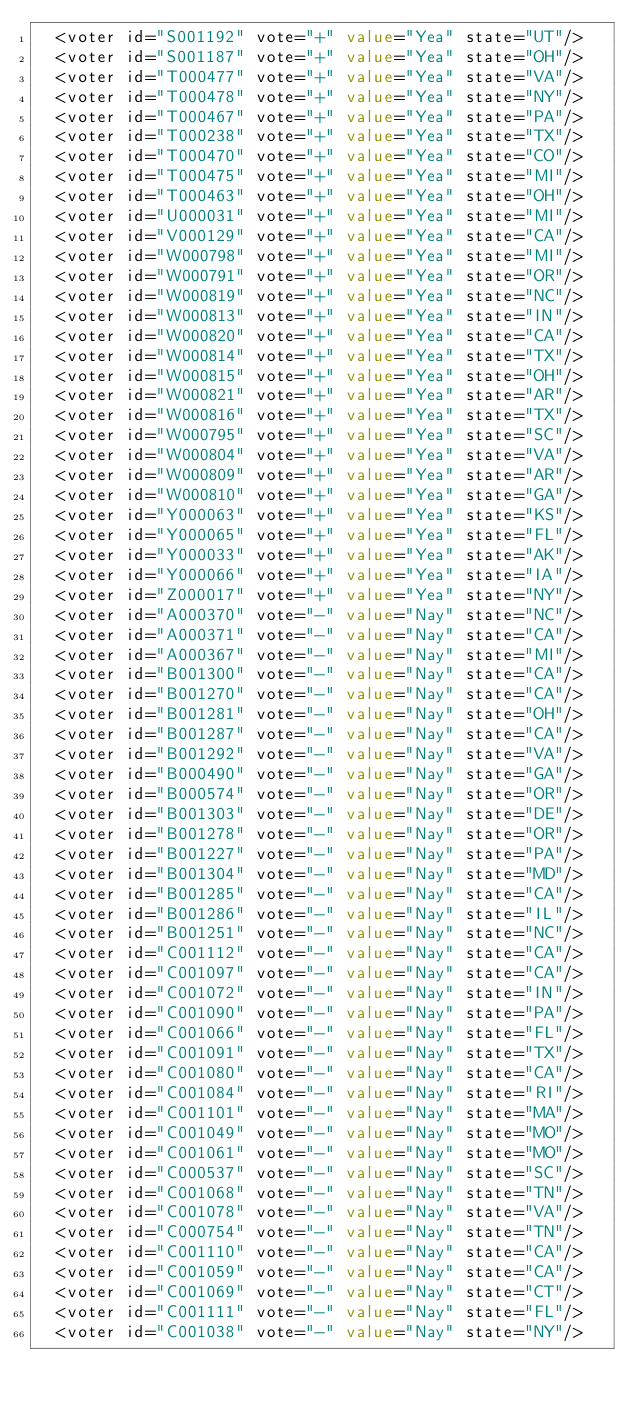Convert code to text. <code><loc_0><loc_0><loc_500><loc_500><_XML_>  <voter id="S001192" vote="+" value="Yea" state="UT"/>
  <voter id="S001187" vote="+" value="Yea" state="OH"/>
  <voter id="T000477" vote="+" value="Yea" state="VA"/>
  <voter id="T000478" vote="+" value="Yea" state="NY"/>
  <voter id="T000467" vote="+" value="Yea" state="PA"/>
  <voter id="T000238" vote="+" value="Yea" state="TX"/>
  <voter id="T000470" vote="+" value="Yea" state="CO"/>
  <voter id="T000475" vote="+" value="Yea" state="MI"/>
  <voter id="T000463" vote="+" value="Yea" state="OH"/>
  <voter id="U000031" vote="+" value="Yea" state="MI"/>
  <voter id="V000129" vote="+" value="Yea" state="CA"/>
  <voter id="W000798" vote="+" value="Yea" state="MI"/>
  <voter id="W000791" vote="+" value="Yea" state="OR"/>
  <voter id="W000819" vote="+" value="Yea" state="NC"/>
  <voter id="W000813" vote="+" value="Yea" state="IN"/>
  <voter id="W000820" vote="+" value="Yea" state="CA"/>
  <voter id="W000814" vote="+" value="Yea" state="TX"/>
  <voter id="W000815" vote="+" value="Yea" state="OH"/>
  <voter id="W000821" vote="+" value="Yea" state="AR"/>
  <voter id="W000816" vote="+" value="Yea" state="TX"/>
  <voter id="W000795" vote="+" value="Yea" state="SC"/>
  <voter id="W000804" vote="+" value="Yea" state="VA"/>
  <voter id="W000809" vote="+" value="Yea" state="AR"/>
  <voter id="W000810" vote="+" value="Yea" state="GA"/>
  <voter id="Y000063" vote="+" value="Yea" state="KS"/>
  <voter id="Y000065" vote="+" value="Yea" state="FL"/>
  <voter id="Y000033" vote="+" value="Yea" state="AK"/>
  <voter id="Y000066" vote="+" value="Yea" state="IA"/>
  <voter id="Z000017" vote="+" value="Yea" state="NY"/>
  <voter id="A000370" vote="-" value="Nay" state="NC"/>
  <voter id="A000371" vote="-" value="Nay" state="CA"/>
  <voter id="A000367" vote="-" value="Nay" state="MI"/>
  <voter id="B001300" vote="-" value="Nay" state="CA"/>
  <voter id="B001270" vote="-" value="Nay" state="CA"/>
  <voter id="B001281" vote="-" value="Nay" state="OH"/>
  <voter id="B001287" vote="-" value="Nay" state="CA"/>
  <voter id="B001292" vote="-" value="Nay" state="VA"/>
  <voter id="B000490" vote="-" value="Nay" state="GA"/>
  <voter id="B000574" vote="-" value="Nay" state="OR"/>
  <voter id="B001303" vote="-" value="Nay" state="DE"/>
  <voter id="B001278" vote="-" value="Nay" state="OR"/>
  <voter id="B001227" vote="-" value="Nay" state="PA"/>
  <voter id="B001304" vote="-" value="Nay" state="MD"/>
  <voter id="B001285" vote="-" value="Nay" state="CA"/>
  <voter id="B001286" vote="-" value="Nay" state="IL"/>
  <voter id="B001251" vote="-" value="Nay" state="NC"/>
  <voter id="C001112" vote="-" value="Nay" state="CA"/>
  <voter id="C001097" vote="-" value="Nay" state="CA"/>
  <voter id="C001072" vote="-" value="Nay" state="IN"/>
  <voter id="C001090" vote="-" value="Nay" state="PA"/>
  <voter id="C001066" vote="-" value="Nay" state="FL"/>
  <voter id="C001091" vote="-" value="Nay" state="TX"/>
  <voter id="C001080" vote="-" value="Nay" state="CA"/>
  <voter id="C001084" vote="-" value="Nay" state="RI"/>
  <voter id="C001101" vote="-" value="Nay" state="MA"/>
  <voter id="C001049" vote="-" value="Nay" state="MO"/>
  <voter id="C001061" vote="-" value="Nay" state="MO"/>
  <voter id="C000537" vote="-" value="Nay" state="SC"/>
  <voter id="C001068" vote="-" value="Nay" state="TN"/>
  <voter id="C001078" vote="-" value="Nay" state="VA"/>
  <voter id="C000754" vote="-" value="Nay" state="TN"/>
  <voter id="C001110" vote="-" value="Nay" state="CA"/>
  <voter id="C001059" vote="-" value="Nay" state="CA"/>
  <voter id="C001069" vote="-" value="Nay" state="CT"/>
  <voter id="C001111" vote="-" value="Nay" state="FL"/>
  <voter id="C001038" vote="-" value="Nay" state="NY"/></code> 